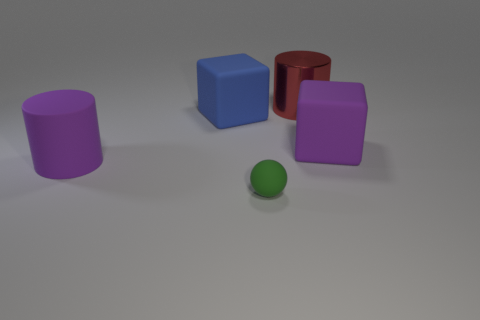There is a purple matte object that is the same shape as the large red metal thing; what size is it?
Your answer should be very brief. Large. What shape is the matte thing that is to the right of the green matte object?
Keep it short and to the point. Cube. Does the large shiny thing have the same shape as the purple object that is to the left of the green rubber sphere?
Offer a very short reply. Yes. Are there the same number of large metal cylinders that are in front of the large purple cylinder and big metallic cylinders in front of the large red thing?
Your answer should be compact. Yes. There is a big rubber thing behind the purple block; is it the same color as the large object that is on the left side of the blue thing?
Keep it short and to the point. No. Are there more purple rubber cylinders that are on the right side of the red object than big shiny objects?
Your response must be concise. No. What is the blue thing made of?
Offer a very short reply. Rubber. What is the shape of the other blue thing that is made of the same material as the tiny thing?
Ensure brevity in your answer.  Cube. What is the size of the rubber thing behind the big object right of the big red cylinder?
Keep it short and to the point. Large. What color is the large cylinder in front of the large blue matte thing?
Give a very brief answer. Purple. 